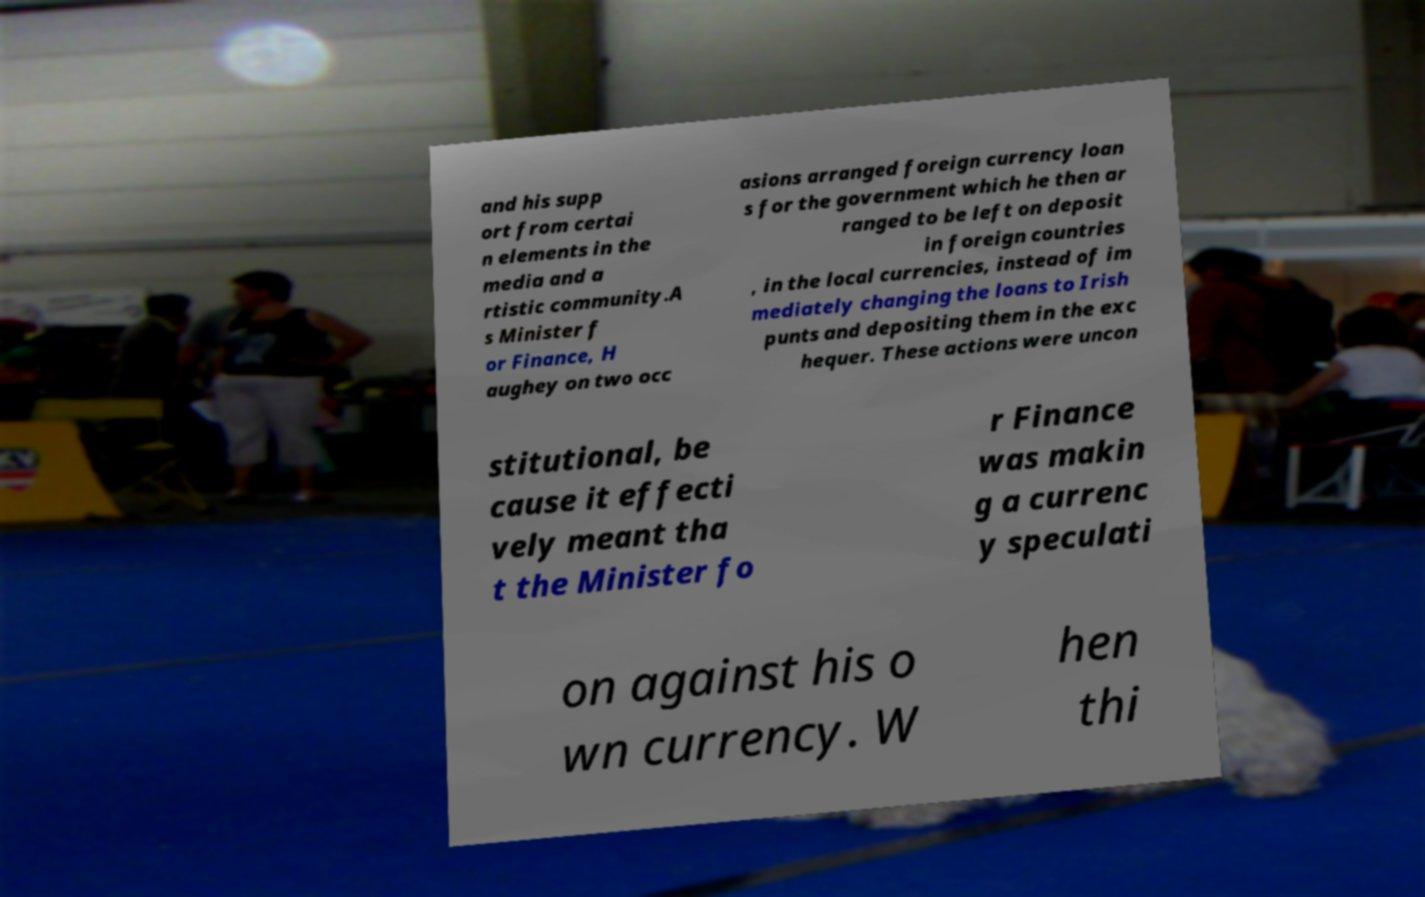There's text embedded in this image that I need extracted. Can you transcribe it verbatim? and his supp ort from certai n elements in the media and a rtistic community.A s Minister f or Finance, H aughey on two occ asions arranged foreign currency loan s for the government which he then ar ranged to be left on deposit in foreign countries , in the local currencies, instead of im mediately changing the loans to Irish punts and depositing them in the exc hequer. These actions were uncon stitutional, be cause it effecti vely meant tha t the Minister fo r Finance was makin g a currenc y speculati on against his o wn currency. W hen thi 